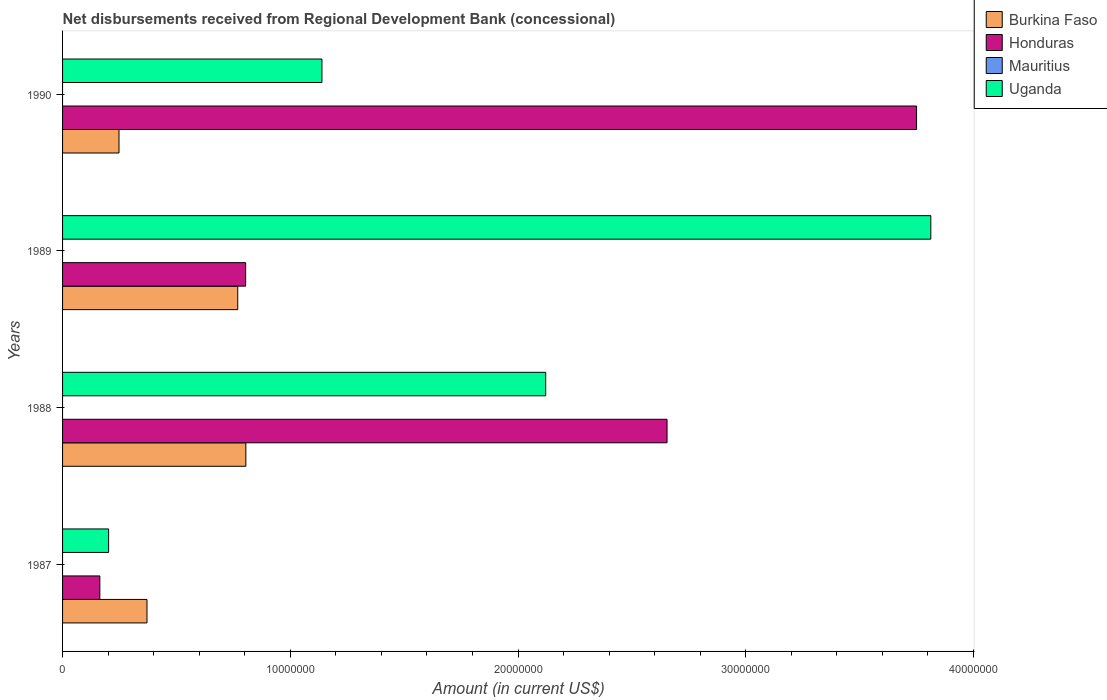Are the number of bars on each tick of the Y-axis equal?
Keep it short and to the point. Yes. How many bars are there on the 1st tick from the top?
Provide a short and direct response. 3. How many bars are there on the 4th tick from the bottom?
Offer a very short reply. 3. In how many cases, is the number of bars for a given year not equal to the number of legend labels?
Your answer should be compact. 4. What is the amount of disbursements received from Regional Development Bank in Mauritius in 1987?
Offer a terse response. 0. Across all years, what is the maximum amount of disbursements received from Regional Development Bank in Burkina Faso?
Give a very brief answer. 8.05e+06. Across all years, what is the minimum amount of disbursements received from Regional Development Bank in Honduras?
Make the answer very short. 1.64e+06. What is the difference between the amount of disbursements received from Regional Development Bank in Burkina Faso in 1987 and that in 1990?
Keep it short and to the point. 1.23e+06. What is the difference between the amount of disbursements received from Regional Development Bank in Mauritius in 1990 and the amount of disbursements received from Regional Development Bank in Uganda in 1987?
Offer a very short reply. -2.02e+06. What is the average amount of disbursements received from Regional Development Bank in Honduras per year?
Offer a terse response. 1.84e+07. In the year 1990, what is the difference between the amount of disbursements received from Regional Development Bank in Honduras and amount of disbursements received from Regional Development Bank in Burkina Faso?
Your answer should be very brief. 3.50e+07. In how many years, is the amount of disbursements received from Regional Development Bank in Honduras greater than 16000000 US$?
Provide a succinct answer. 2. What is the ratio of the amount of disbursements received from Regional Development Bank in Honduras in 1988 to that in 1990?
Provide a short and direct response. 0.71. Is the difference between the amount of disbursements received from Regional Development Bank in Honduras in 1989 and 1990 greater than the difference between the amount of disbursements received from Regional Development Bank in Burkina Faso in 1989 and 1990?
Keep it short and to the point. No. What is the difference between the highest and the second highest amount of disbursements received from Regional Development Bank in Burkina Faso?
Your answer should be very brief. 3.56e+05. What is the difference between the highest and the lowest amount of disbursements received from Regional Development Bank in Uganda?
Offer a very short reply. 3.61e+07. In how many years, is the amount of disbursements received from Regional Development Bank in Burkina Faso greater than the average amount of disbursements received from Regional Development Bank in Burkina Faso taken over all years?
Keep it short and to the point. 2. Is the sum of the amount of disbursements received from Regional Development Bank in Burkina Faso in 1989 and 1990 greater than the maximum amount of disbursements received from Regional Development Bank in Honduras across all years?
Your response must be concise. No. How many bars are there?
Make the answer very short. 12. How many years are there in the graph?
Make the answer very short. 4. What is the difference between two consecutive major ticks on the X-axis?
Ensure brevity in your answer.  1.00e+07. Are the values on the major ticks of X-axis written in scientific E-notation?
Your response must be concise. No. How are the legend labels stacked?
Your answer should be compact. Vertical. What is the title of the graph?
Provide a short and direct response. Net disbursements received from Regional Development Bank (concessional). Does "Cuba" appear as one of the legend labels in the graph?
Offer a very short reply. No. What is the label or title of the Y-axis?
Your answer should be very brief. Years. What is the Amount (in current US$) of Burkina Faso in 1987?
Provide a succinct answer. 3.71e+06. What is the Amount (in current US$) in Honduras in 1987?
Provide a succinct answer. 1.64e+06. What is the Amount (in current US$) of Uganda in 1987?
Make the answer very short. 2.02e+06. What is the Amount (in current US$) of Burkina Faso in 1988?
Give a very brief answer. 8.05e+06. What is the Amount (in current US$) in Honduras in 1988?
Make the answer very short. 2.65e+07. What is the Amount (in current US$) of Mauritius in 1988?
Your response must be concise. 0. What is the Amount (in current US$) in Uganda in 1988?
Offer a terse response. 2.12e+07. What is the Amount (in current US$) in Burkina Faso in 1989?
Ensure brevity in your answer.  7.69e+06. What is the Amount (in current US$) in Honduras in 1989?
Ensure brevity in your answer.  8.04e+06. What is the Amount (in current US$) of Mauritius in 1989?
Your answer should be compact. 0. What is the Amount (in current US$) of Uganda in 1989?
Your response must be concise. 3.81e+07. What is the Amount (in current US$) of Burkina Faso in 1990?
Make the answer very short. 2.48e+06. What is the Amount (in current US$) of Honduras in 1990?
Make the answer very short. 3.75e+07. What is the Amount (in current US$) in Mauritius in 1990?
Your answer should be compact. 0. What is the Amount (in current US$) of Uganda in 1990?
Keep it short and to the point. 1.14e+07. Across all years, what is the maximum Amount (in current US$) in Burkina Faso?
Ensure brevity in your answer.  8.05e+06. Across all years, what is the maximum Amount (in current US$) in Honduras?
Offer a very short reply. 3.75e+07. Across all years, what is the maximum Amount (in current US$) in Uganda?
Ensure brevity in your answer.  3.81e+07. Across all years, what is the minimum Amount (in current US$) in Burkina Faso?
Keep it short and to the point. 2.48e+06. Across all years, what is the minimum Amount (in current US$) of Honduras?
Provide a succinct answer. 1.64e+06. Across all years, what is the minimum Amount (in current US$) of Uganda?
Keep it short and to the point. 2.02e+06. What is the total Amount (in current US$) in Burkina Faso in the graph?
Ensure brevity in your answer.  2.19e+07. What is the total Amount (in current US$) in Honduras in the graph?
Your answer should be compact. 7.37e+07. What is the total Amount (in current US$) in Mauritius in the graph?
Offer a terse response. 0. What is the total Amount (in current US$) of Uganda in the graph?
Offer a very short reply. 7.28e+07. What is the difference between the Amount (in current US$) of Burkina Faso in 1987 and that in 1988?
Your response must be concise. -4.34e+06. What is the difference between the Amount (in current US$) in Honduras in 1987 and that in 1988?
Provide a short and direct response. -2.49e+07. What is the difference between the Amount (in current US$) in Uganda in 1987 and that in 1988?
Your response must be concise. -1.92e+07. What is the difference between the Amount (in current US$) in Burkina Faso in 1987 and that in 1989?
Give a very brief answer. -3.98e+06. What is the difference between the Amount (in current US$) of Honduras in 1987 and that in 1989?
Provide a short and direct response. -6.40e+06. What is the difference between the Amount (in current US$) in Uganda in 1987 and that in 1989?
Your response must be concise. -3.61e+07. What is the difference between the Amount (in current US$) of Burkina Faso in 1987 and that in 1990?
Your response must be concise. 1.23e+06. What is the difference between the Amount (in current US$) of Honduras in 1987 and that in 1990?
Provide a succinct answer. -3.59e+07. What is the difference between the Amount (in current US$) of Uganda in 1987 and that in 1990?
Your response must be concise. -9.37e+06. What is the difference between the Amount (in current US$) of Burkina Faso in 1988 and that in 1989?
Offer a terse response. 3.56e+05. What is the difference between the Amount (in current US$) of Honduras in 1988 and that in 1989?
Provide a short and direct response. 1.85e+07. What is the difference between the Amount (in current US$) in Uganda in 1988 and that in 1989?
Make the answer very short. -1.69e+07. What is the difference between the Amount (in current US$) of Burkina Faso in 1988 and that in 1990?
Offer a very short reply. 5.57e+06. What is the difference between the Amount (in current US$) in Honduras in 1988 and that in 1990?
Provide a short and direct response. -1.10e+07. What is the difference between the Amount (in current US$) of Uganda in 1988 and that in 1990?
Give a very brief answer. 9.83e+06. What is the difference between the Amount (in current US$) of Burkina Faso in 1989 and that in 1990?
Your answer should be compact. 5.21e+06. What is the difference between the Amount (in current US$) of Honduras in 1989 and that in 1990?
Make the answer very short. -2.95e+07. What is the difference between the Amount (in current US$) of Uganda in 1989 and that in 1990?
Provide a short and direct response. 2.67e+07. What is the difference between the Amount (in current US$) of Burkina Faso in 1987 and the Amount (in current US$) of Honduras in 1988?
Your response must be concise. -2.28e+07. What is the difference between the Amount (in current US$) in Burkina Faso in 1987 and the Amount (in current US$) in Uganda in 1988?
Give a very brief answer. -1.75e+07. What is the difference between the Amount (in current US$) in Honduras in 1987 and the Amount (in current US$) in Uganda in 1988?
Give a very brief answer. -1.96e+07. What is the difference between the Amount (in current US$) in Burkina Faso in 1987 and the Amount (in current US$) in Honduras in 1989?
Your answer should be compact. -4.33e+06. What is the difference between the Amount (in current US$) in Burkina Faso in 1987 and the Amount (in current US$) in Uganda in 1989?
Keep it short and to the point. -3.44e+07. What is the difference between the Amount (in current US$) of Honduras in 1987 and the Amount (in current US$) of Uganda in 1989?
Your answer should be compact. -3.65e+07. What is the difference between the Amount (in current US$) of Burkina Faso in 1987 and the Amount (in current US$) of Honduras in 1990?
Keep it short and to the point. -3.38e+07. What is the difference between the Amount (in current US$) in Burkina Faso in 1987 and the Amount (in current US$) in Uganda in 1990?
Provide a short and direct response. -7.68e+06. What is the difference between the Amount (in current US$) in Honduras in 1987 and the Amount (in current US$) in Uganda in 1990?
Give a very brief answer. -9.75e+06. What is the difference between the Amount (in current US$) of Burkina Faso in 1988 and the Amount (in current US$) of Honduras in 1989?
Keep it short and to the point. 8000. What is the difference between the Amount (in current US$) of Burkina Faso in 1988 and the Amount (in current US$) of Uganda in 1989?
Ensure brevity in your answer.  -3.01e+07. What is the difference between the Amount (in current US$) in Honduras in 1988 and the Amount (in current US$) in Uganda in 1989?
Provide a short and direct response. -1.16e+07. What is the difference between the Amount (in current US$) in Burkina Faso in 1988 and the Amount (in current US$) in Honduras in 1990?
Provide a short and direct response. -2.95e+07. What is the difference between the Amount (in current US$) in Burkina Faso in 1988 and the Amount (in current US$) in Uganda in 1990?
Ensure brevity in your answer.  -3.34e+06. What is the difference between the Amount (in current US$) of Honduras in 1988 and the Amount (in current US$) of Uganda in 1990?
Give a very brief answer. 1.52e+07. What is the difference between the Amount (in current US$) of Burkina Faso in 1989 and the Amount (in current US$) of Honduras in 1990?
Your answer should be very brief. -2.98e+07. What is the difference between the Amount (in current US$) in Burkina Faso in 1989 and the Amount (in current US$) in Uganda in 1990?
Your answer should be very brief. -3.70e+06. What is the difference between the Amount (in current US$) of Honduras in 1989 and the Amount (in current US$) of Uganda in 1990?
Ensure brevity in your answer.  -3.35e+06. What is the average Amount (in current US$) in Burkina Faso per year?
Make the answer very short. 5.48e+06. What is the average Amount (in current US$) of Honduras per year?
Provide a short and direct response. 1.84e+07. What is the average Amount (in current US$) of Uganda per year?
Your answer should be compact. 1.82e+07. In the year 1987, what is the difference between the Amount (in current US$) of Burkina Faso and Amount (in current US$) of Honduras?
Offer a terse response. 2.07e+06. In the year 1987, what is the difference between the Amount (in current US$) of Burkina Faso and Amount (in current US$) of Uganda?
Make the answer very short. 1.68e+06. In the year 1987, what is the difference between the Amount (in current US$) in Honduras and Amount (in current US$) in Uganda?
Make the answer very short. -3.85e+05. In the year 1988, what is the difference between the Amount (in current US$) in Burkina Faso and Amount (in current US$) in Honduras?
Your answer should be compact. -1.85e+07. In the year 1988, what is the difference between the Amount (in current US$) in Burkina Faso and Amount (in current US$) in Uganda?
Give a very brief answer. -1.32e+07. In the year 1988, what is the difference between the Amount (in current US$) in Honduras and Amount (in current US$) in Uganda?
Offer a very short reply. 5.33e+06. In the year 1989, what is the difference between the Amount (in current US$) of Burkina Faso and Amount (in current US$) of Honduras?
Make the answer very short. -3.48e+05. In the year 1989, what is the difference between the Amount (in current US$) of Burkina Faso and Amount (in current US$) of Uganda?
Give a very brief answer. -3.04e+07. In the year 1989, what is the difference between the Amount (in current US$) of Honduras and Amount (in current US$) of Uganda?
Make the answer very short. -3.01e+07. In the year 1990, what is the difference between the Amount (in current US$) of Burkina Faso and Amount (in current US$) of Honduras?
Offer a terse response. -3.50e+07. In the year 1990, what is the difference between the Amount (in current US$) of Burkina Faso and Amount (in current US$) of Uganda?
Your response must be concise. -8.91e+06. In the year 1990, what is the difference between the Amount (in current US$) of Honduras and Amount (in current US$) of Uganda?
Give a very brief answer. 2.61e+07. What is the ratio of the Amount (in current US$) in Burkina Faso in 1987 to that in 1988?
Your response must be concise. 0.46. What is the ratio of the Amount (in current US$) of Honduras in 1987 to that in 1988?
Keep it short and to the point. 0.06. What is the ratio of the Amount (in current US$) of Uganda in 1987 to that in 1988?
Your answer should be compact. 0.1. What is the ratio of the Amount (in current US$) of Burkina Faso in 1987 to that in 1989?
Ensure brevity in your answer.  0.48. What is the ratio of the Amount (in current US$) in Honduras in 1987 to that in 1989?
Give a very brief answer. 0.2. What is the ratio of the Amount (in current US$) in Uganda in 1987 to that in 1989?
Keep it short and to the point. 0.05. What is the ratio of the Amount (in current US$) of Burkina Faso in 1987 to that in 1990?
Offer a very short reply. 1.5. What is the ratio of the Amount (in current US$) in Honduras in 1987 to that in 1990?
Provide a short and direct response. 0.04. What is the ratio of the Amount (in current US$) in Uganda in 1987 to that in 1990?
Your answer should be compact. 0.18. What is the ratio of the Amount (in current US$) in Burkina Faso in 1988 to that in 1989?
Ensure brevity in your answer.  1.05. What is the ratio of the Amount (in current US$) of Honduras in 1988 to that in 1989?
Your answer should be very brief. 3.3. What is the ratio of the Amount (in current US$) of Uganda in 1988 to that in 1989?
Offer a terse response. 0.56. What is the ratio of the Amount (in current US$) in Burkina Faso in 1988 to that in 1990?
Make the answer very short. 3.25. What is the ratio of the Amount (in current US$) of Honduras in 1988 to that in 1990?
Give a very brief answer. 0.71. What is the ratio of the Amount (in current US$) of Uganda in 1988 to that in 1990?
Offer a terse response. 1.86. What is the ratio of the Amount (in current US$) of Burkina Faso in 1989 to that in 1990?
Your answer should be compact. 3.1. What is the ratio of the Amount (in current US$) in Honduras in 1989 to that in 1990?
Make the answer very short. 0.21. What is the ratio of the Amount (in current US$) in Uganda in 1989 to that in 1990?
Make the answer very short. 3.35. What is the difference between the highest and the second highest Amount (in current US$) of Burkina Faso?
Ensure brevity in your answer.  3.56e+05. What is the difference between the highest and the second highest Amount (in current US$) of Honduras?
Your answer should be very brief. 1.10e+07. What is the difference between the highest and the second highest Amount (in current US$) in Uganda?
Keep it short and to the point. 1.69e+07. What is the difference between the highest and the lowest Amount (in current US$) in Burkina Faso?
Provide a short and direct response. 5.57e+06. What is the difference between the highest and the lowest Amount (in current US$) in Honduras?
Make the answer very short. 3.59e+07. What is the difference between the highest and the lowest Amount (in current US$) in Uganda?
Offer a terse response. 3.61e+07. 